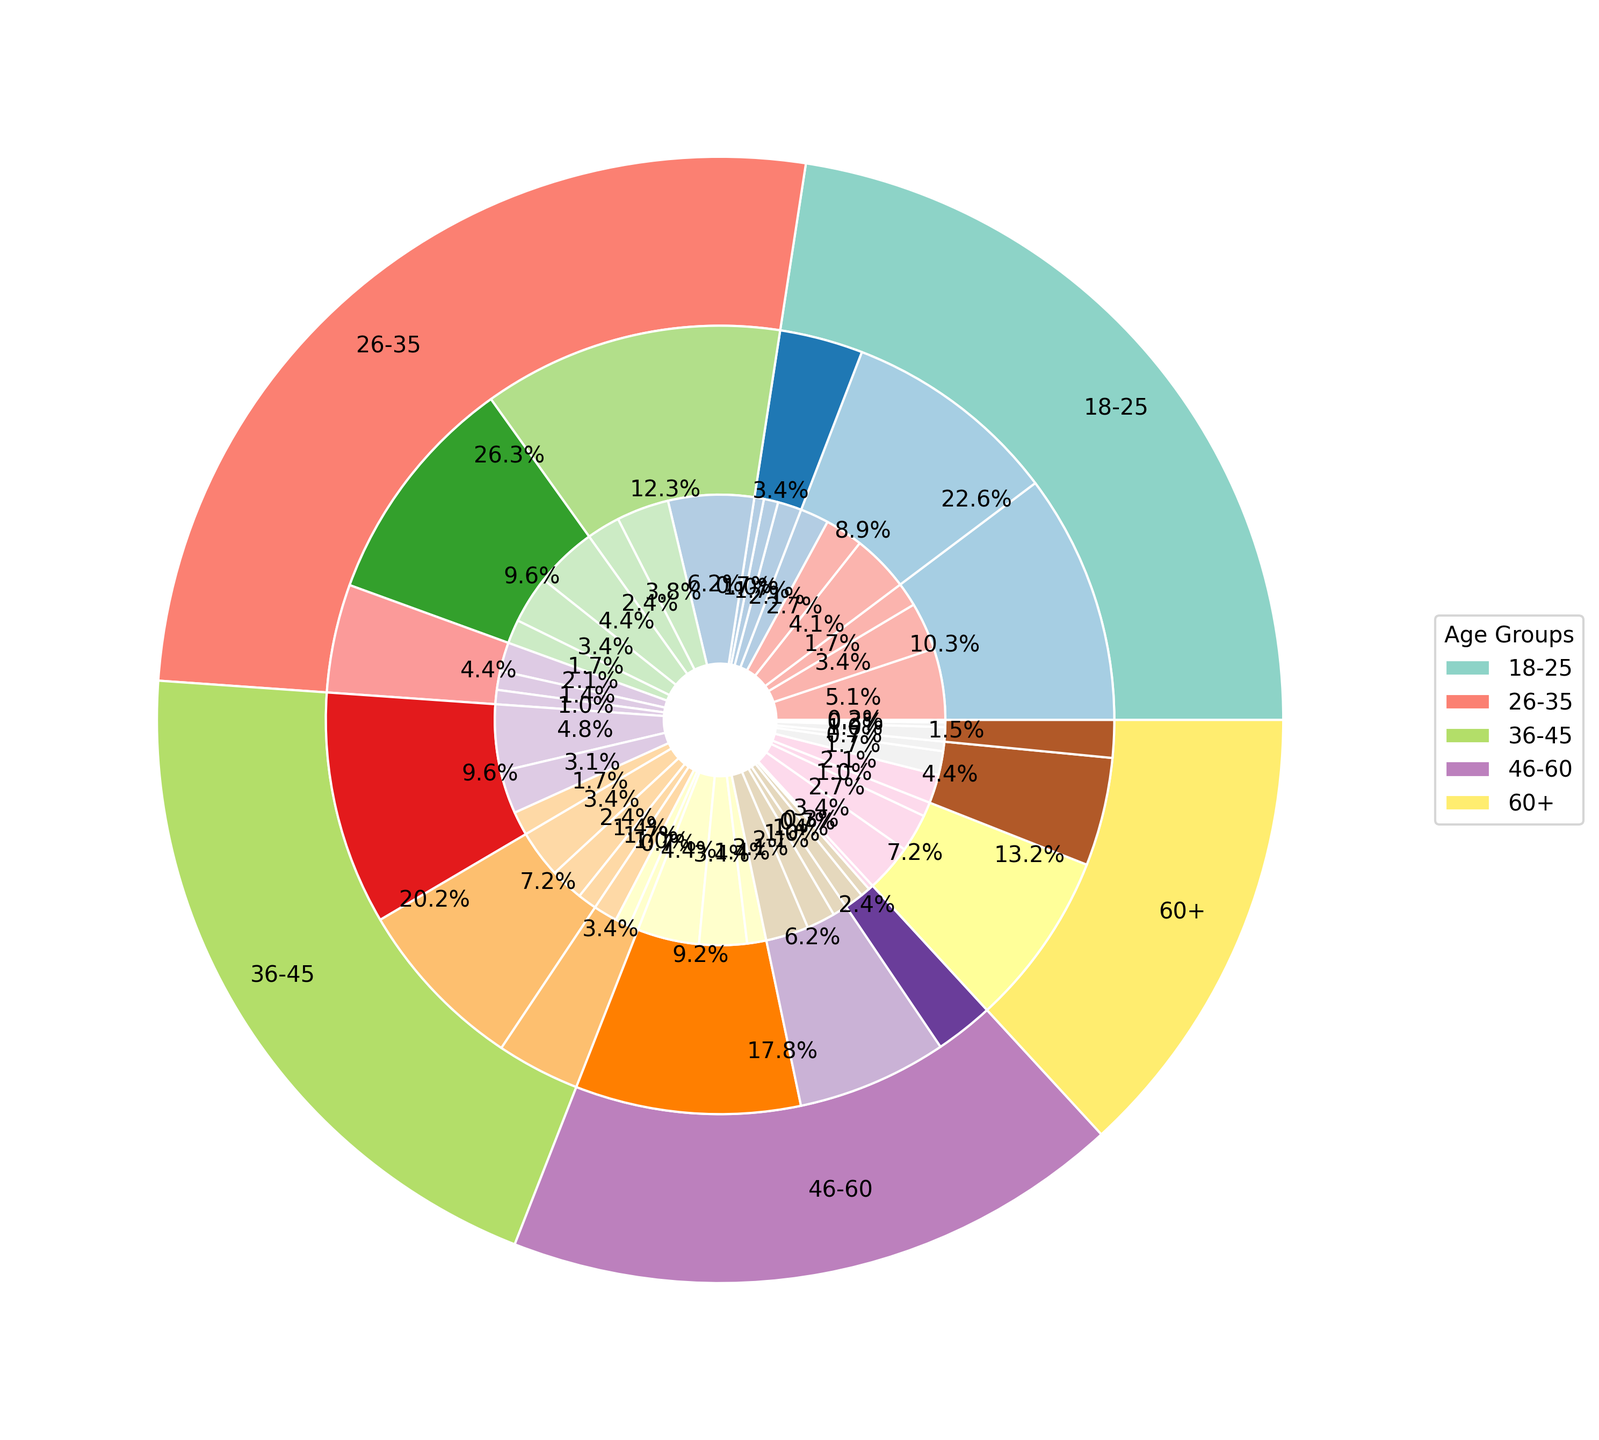What's the most common frequency of use among 18-25-year-olds with a medium income level? Look at the segment for 18-25-year-olds with a medium income level. Among the daily, weekly, and monthly users, the daily users have the highest proportion.
Answer: Daily Which age group has the highest overall count of public transportation users? Compare the outermost segments of each age group. The 26-35 age group has the largest segment.
Answer: 26-35 For 46-60-year-olds, which income level has the least frequent public transportation users monthly? Examine the segments under 46-60-year-olds for the monthly category. The high-income level has the smallest proportion.
Answer: High How do the daily users in the 36-45 age group compare to weekly users in the same age group? Compare the inner ring segment sizes for 36-45 daily and weekly users across all income levels. Daily users have a larger segment.
Answer: Daily users are more Sum the counts of monthly users for all age groups, and determine which age group contributes the highest count. Add up the monthly counts for each age group. The sums are 130 (18-25), 150 (26-35), 110 (36-45), 80 (46-60), and 55 (60+). The highest count belongs to the 26-35 age group.
Answer: 26-35 Between medium-income and high-income groups, which one has more daily users in the 26-35 age group? Compare the sizes of the middle ring segments (medium and high income) for daily use in 26-35 age group. The medium income segment is larger.
Answer: Medium income group What is the total number of weekly users across all age groups? Sum all the counts for weekly users: (100+80+30+110+100+40+90+70+30+100+60+20+80+50+10) = 960.
Answer: 960 How does the number of monthly users in the 60+ age group compare to the number of monthly users in the 46-60 age group? Compare the sizes of the inner ring segments for monthly users in 60+ and 46-60 age groups. The 46-60 age group has a larger segment.
Answer: 60+ group has fewer users Which income level among 18-25-year-olds has the most users, regardless of frequency? Sum the counts for each income level across all frequencies for 18-25: Low (150+100+50 = 300), Medium (120+80+60 = 260), High (50+30+20 = 100). The low-income level has the most users.
Answer: Low income level 